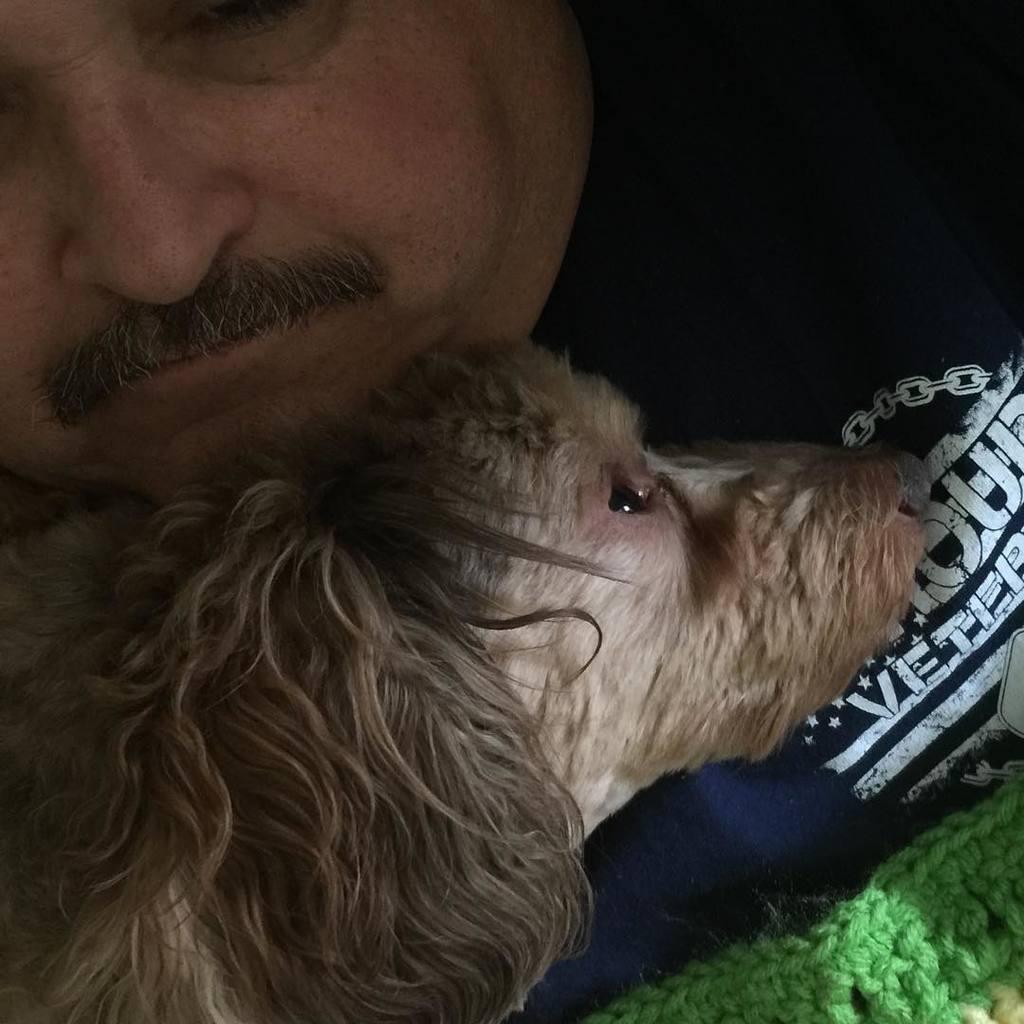Could you give a brief overview of what you see in this image? In this picture there is a person with mustaches holding a dog, dog is brown in color. The person is having a black color t shirt. 